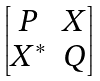<formula> <loc_0><loc_0><loc_500><loc_500>\begin{bmatrix} P & X \\ X ^ { * } & Q \end{bmatrix}</formula> 